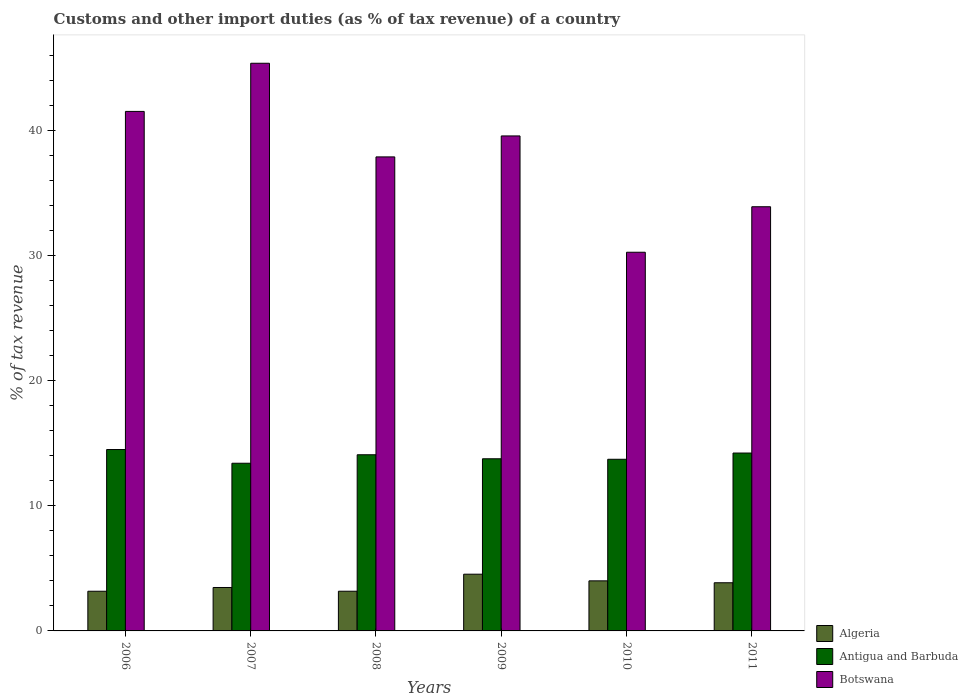How many groups of bars are there?
Your answer should be very brief. 6. Are the number of bars per tick equal to the number of legend labels?
Offer a terse response. Yes. What is the label of the 6th group of bars from the left?
Your response must be concise. 2011. What is the percentage of tax revenue from customs in Algeria in 2009?
Give a very brief answer. 4.53. Across all years, what is the maximum percentage of tax revenue from customs in Antigua and Barbuda?
Make the answer very short. 14.5. Across all years, what is the minimum percentage of tax revenue from customs in Botswana?
Provide a short and direct response. 30.27. In which year was the percentage of tax revenue from customs in Algeria minimum?
Provide a succinct answer. 2006. What is the total percentage of tax revenue from customs in Antigua and Barbuda in the graph?
Keep it short and to the point. 83.68. What is the difference between the percentage of tax revenue from customs in Algeria in 2009 and that in 2010?
Your answer should be very brief. 0.53. What is the difference between the percentage of tax revenue from customs in Antigua and Barbuda in 2008 and the percentage of tax revenue from customs in Algeria in 2006?
Provide a short and direct response. 10.91. What is the average percentage of tax revenue from customs in Algeria per year?
Offer a terse response. 3.7. In the year 2008, what is the difference between the percentage of tax revenue from customs in Antigua and Barbuda and percentage of tax revenue from customs in Botswana?
Provide a short and direct response. -23.81. What is the ratio of the percentage of tax revenue from customs in Antigua and Barbuda in 2006 to that in 2010?
Your answer should be very brief. 1.06. Is the difference between the percentage of tax revenue from customs in Antigua and Barbuda in 2008 and 2011 greater than the difference between the percentage of tax revenue from customs in Botswana in 2008 and 2011?
Your response must be concise. No. What is the difference between the highest and the second highest percentage of tax revenue from customs in Botswana?
Offer a terse response. 3.85. What is the difference between the highest and the lowest percentage of tax revenue from customs in Botswana?
Make the answer very short. 15.11. In how many years, is the percentage of tax revenue from customs in Botswana greater than the average percentage of tax revenue from customs in Botswana taken over all years?
Provide a short and direct response. 3. Is the sum of the percentage of tax revenue from customs in Botswana in 2007 and 2009 greater than the maximum percentage of tax revenue from customs in Antigua and Barbuda across all years?
Offer a terse response. Yes. What does the 3rd bar from the left in 2008 represents?
Your answer should be compact. Botswana. What does the 2nd bar from the right in 2009 represents?
Your response must be concise. Antigua and Barbuda. How many bars are there?
Your answer should be very brief. 18. Are all the bars in the graph horizontal?
Offer a terse response. No. How many years are there in the graph?
Ensure brevity in your answer.  6. Are the values on the major ticks of Y-axis written in scientific E-notation?
Your answer should be compact. No. How are the legend labels stacked?
Your answer should be compact. Vertical. What is the title of the graph?
Provide a short and direct response. Customs and other import duties (as % of tax revenue) of a country. Does "Isle of Man" appear as one of the legend labels in the graph?
Your answer should be compact. No. What is the label or title of the Y-axis?
Your response must be concise. % of tax revenue. What is the % of tax revenue of Algeria in 2006?
Ensure brevity in your answer.  3.17. What is the % of tax revenue of Antigua and Barbuda in 2006?
Give a very brief answer. 14.5. What is the % of tax revenue in Botswana in 2006?
Make the answer very short. 41.53. What is the % of tax revenue in Algeria in 2007?
Your answer should be very brief. 3.47. What is the % of tax revenue of Antigua and Barbuda in 2007?
Provide a succinct answer. 13.4. What is the % of tax revenue in Botswana in 2007?
Give a very brief answer. 45.37. What is the % of tax revenue of Algeria in 2008?
Offer a terse response. 3.17. What is the % of tax revenue in Antigua and Barbuda in 2008?
Give a very brief answer. 14.08. What is the % of tax revenue in Botswana in 2008?
Your answer should be very brief. 37.89. What is the % of tax revenue in Algeria in 2009?
Offer a terse response. 4.53. What is the % of tax revenue in Antigua and Barbuda in 2009?
Provide a succinct answer. 13.76. What is the % of tax revenue of Botswana in 2009?
Offer a very short reply. 39.57. What is the % of tax revenue in Algeria in 2010?
Provide a succinct answer. 4. What is the % of tax revenue in Antigua and Barbuda in 2010?
Ensure brevity in your answer.  13.72. What is the % of tax revenue of Botswana in 2010?
Your answer should be compact. 30.27. What is the % of tax revenue in Algeria in 2011?
Offer a very short reply. 3.85. What is the % of tax revenue in Antigua and Barbuda in 2011?
Ensure brevity in your answer.  14.22. What is the % of tax revenue of Botswana in 2011?
Provide a succinct answer. 33.91. Across all years, what is the maximum % of tax revenue in Algeria?
Ensure brevity in your answer.  4.53. Across all years, what is the maximum % of tax revenue of Antigua and Barbuda?
Offer a terse response. 14.5. Across all years, what is the maximum % of tax revenue in Botswana?
Provide a succinct answer. 45.37. Across all years, what is the minimum % of tax revenue in Algeria?
Provide a succinct answer. 3.17. Across all years, what is the minimum % of tax revenue in Antigua and Barbuda?
Your answer should be very brief. 13.4. Across all years, what is the minimum % of tax revenue of Botswana?
Your response must be concise. 30.27. What is the total % of tax revenue in Algeria in the graph?
Offer a very short reply. 22.2. What is the total % of tax revenue in Antigua and Barbuda in the graph?
Keep it short and to the point. 83.68. What is the total % of tax revenue of Botswana in the graph?
Your answer should be compact. 228.53. What is the difference between the % of tax revenue in Algeria in 2006 and that in 2007?
Your answer should be compact. -0.3. What is the difference between the % of tax revenue in Antigua and Barbuda in 2006 and that in 2007?
Provide a short and direct response. 1.1. What is the difference between the % of tax revenue of Botswana in 2006 and that in 2007?
Give a very brief answer. -3.85. What is the difference between the % of tax revenue in Algeria in 2006 and that in 2008?
Your response must be concise. -0. What is the difference between the % of tax revenue in Antigua and Barbuda in 2006 and that in 2008?
Give a very brief answer. 0.42. What is the difference between the % of tax revenue of Botswana in 2006 and that in 2008?
Your answer should be very brief. 3.64. What is the difference between the % of tax revenue of Algeria in 2006 and that in 2009?
Make the answer very short. -1.36. What is the difference between the % of tax revenue of Antigua and Barbuda in 2006 and that in 2009?
Your answer should be compact. 0.74. What is the difference between the % of tax revenue of Botswana in 2006 and that in 2009?
Your answer should be compact. 1.96. What is the difference between the % of tax revenue in Algeria in 2006 and that in 2010?
Your response must be concise. -0.83. What is the difference between the % of tax revenue of Antigua and Barbuda in 2006 and that in 2010?
Offer a very short reply. 0.78. What is the difference between the % of tax revenue in Botswana in 2006 and that in 2010?
Ensure brevity in your answer.  11.26. What is the difference between the % of tax revenue of Algeria in 2006 and that in 2011?
Make the answer very short. -0.68. What is the difference between the % of tax revenue of Antigua and Barbuda in 2006 and that in 2011?
Ensure brevity in your answer.  0.28. What is the difference between the % of tax revenue in Botswana in 2006 and that in 2011?
Give a very brief answer. 7.62. What is the difference between the % of tax revenue of Algeria in 2007 and that in 2008?
Offer a terse response. 0.3. What is the difference between the % of tax revenue of Antigua and Barbuda in 2007 and that in 2008?
Provide a succinct answer. -0.68. What is the difference between the % of tax revenue in Botswana in 2007 and that in 2008?
Make the answer very short. 7.48. What is the difference between the % of tax revenue of Algeria in 2007 and that in 2009?
Your answer should be compact. -1.06. What is the difference between the % of tax revenue in Antigua and Barbuda in 2007 and that in 2009?
Your answer should be compact. -0.36. What is the difference between the % of tax revenue of Botswana in 2007 and that in 2009?
Your answer should be very brief. 5.81. What is the difference between the % of tax revenue in Algeria in 2007 and that in 2010?
Your response must be concise. -0.53. What is the difference between the % of tax revenue in Antigua and Barbuda in 2007 and that in 2010?
Make the answer very short. -0.32. What is the difference between the % of tax revenue of Botswana in 2007 and that in 2010?
Offer a terse response. 15.11. What is the difference between the % of tax revenue in Algeria in 2007 and that in 2011?
Your response must be concise. -0.38. What is the difference between the % of tax revenue in Antigua and Barbuda in 2007 and that in 2011?
Ensure brevity in your answer.  -0.82. What is the difference between the % of tax revenue of Botswana in 2007 and that in 2011?
Your response must be concise. 11.47. What is the difference between the % of tax revenue in Algeria in 2008 and that in 2009?
Give a very brief answer. -1.36. What is the difference between the % of tax revenue of Antigua and Barbuda in 2008 and that in 2009?
Ensure brevity in your answer.  0.32. What is the difference between the % of tax revenue in Botswana in 2008 and that in 2009?
Provide a succinct answer. -1.68. What is the difference between the % of tax revenue in Algeria in 2008 and that in 2010?
Keep it short and to the point. -0.83. What is the difference between the % of tax revenue in Antigua and Barbuda in 2008 and that in 2010?
Your answer should be very brief. 0.36. What is the difference between the % of tax revenue of Botswana in 2008 and that in 2010?
Your answer should be very brief. 7.62. What is the difference between the % of tax revenue of Algeria in 2008 and that in 2011?
Provide a short and direct response. -0.68. What is the difference between the % of tax revenue of Antigua and Barbuda in 2008 and that in 2011?
Provide a succinct answer. -0.14. What is the difference between the % of tax revenue of Botswana in 2008 and that in 2011?
Give a very brief answer. 3.98. What is the difference between the % of tax revenue in Algeria in 2009 and that in 2010?
Provide a short and direct response. 0.53. What is the difference between the % of tax revenue in Antigua and Barbuda in 2009 and that in 2010?
Provide a short and direct response. 0.04. What is the difference between the % of tax revenue in Botswana in 2009 and that in 2010?
Make the answer very short. 9.3. What is the difference between the % of tax revenue in Algeria in 2009 and that in 2011?
Provide a short and direct response. 0.68. What is the difference between the % of tax revenue of Antigua and Barbuda in 2009 and that in 2011?
Your answer should be compact. -0.46. What is the difference between the % of tax revenue in Botswana in 2009 and that in 2011?
Your answer should be very brief. 5.66. What is the difference between the % of tax revenue of Algeria in 2010 and that in 2011?
Your answer should be compact. 0.15. What is the difference between the % of tax revenue in Antigua and Barbuda in 2010 and that in 2011?
Ensure brevity in your answer.  -0.5. What is the difference between the % of tax revenue of Botswana in 2010 and that in 2011?
Offer a very short reply. -3.64. What is the difference between the % of tax revenue in Algeria in 2006 and the % of tax revenue in Antigua and Barbuda in 2007?
Your response must be concise. -10.23. What is the difference between the % of tax revenue of Algeria in 2006 and the % of tax revenue of Botswana in 2007?
Give a very brief answer. -42.2. What is the difference between the % of tax revenue of Antigua and Barbuda in 2006 and the % of tax revenue of Botswana in 2007?
Ensure brevity in your answer.  -30.88. What is the difference between the % of tax revenue of Algeria in 2006 and the % of tax revenue of Antigua and Barbuda in 2008?
Your response must be concise. -10.91. What is the difference between the % of tax revenue of Algeria in 2006 and the % of tax revenue of Botswana in 2008?
Ensure brevity in your answer.  -34.72. What is the difference between the % of tax revenue in Antigua and Barbuda in 2006 and the % of tax revenue in Botswana in 2008?
Your answer should be very brief. -23.39. What is the difference between the % of tax revenue in Algeria in 2006 and the % of tax revenue in Antigua and Barbuda in 2009?
Your response must be concise. -10.59. What is the difference between the % of tax revenue in Algeria in 2006 and the % of tax revenue in Botswana in 2009?
Give a very brief answer. -36.4. What is the difference between the % of tax revenue in Antigua and Barbuda in 2006 and the % of tax revenue in Botswana in 2009?
Give a very brief answer. -25.07. What is the difference between the % of tax revenue in Algeria in 2006 and the % of tax revenue in Antigua and Barbuda in 2010?
Make the answer very short. -10.55. What is the difference between the % of tax revenue in Algeria in 2006 and the % of tax revenue in Botswana in 2010?
Provide a short and direct response. -27.1. What is the difference between the % of tax revenue in Antigua and Barbuda in 2006 and the % of tax revenue in Botswana in 2010?
Keep it short and to the point. -15.77. What is the difference between the % of tax revenue in Algeria in 2006 and the % of tax revenue in Antigua and Barbuda in 2011?
Provide a short and direct response. -11.05. What is the difference between the % of tax revenue of Algeria in 2006 and the % of tax revenue of Botswana in 2011?
Provide a short and direct response. -30.73. What is the difference between the % of tax revenue of Antigua and Barbuda in 2006 and the % of tax revenue of Botswana in 2011?
Give a very brief answer. -19.41. What is the difference between the % of tax revenue in Algeria in 2007 and the % of tax revenue in Antigua and Barbuda in 2008?
Keep it short and to the point. -10.61. What is the difference between the % of tax revenue in Algeria in 2007 and the % of tax revenue in Botswana in 2008?
Keep it short and to the point. -34.42. What is the difference between the % of tax revenue of Antigua and Barbuda in 2007 and the % of tax revenue of Botswana in 2008?
Offer a very short reply. -24.49. What is the difference between the % of tax revenue of Algeria in 2007 and the % of tax revenue of Antigua and Barbuda in 2009?
Offer a terse response. -10.29. What is the difference between the % of tax revenue of Algeria in 2007 and the % of tax revenue of Botswana in 2009?
Your answer should be very brief. -36.1. What is the difference between the % of tax revenue of Antigua and Barbuda in 2007 and the % of tax revenue of Botswana in 2009?
Make the answer very short. -26.16. What is the difference between the % of tax revenue of Algeria in 2007 and the % of tax revenue of Antigua and Barbuda in 2010?
Your answer should be compact. -10.25. What is the difference between the % of tax revenue of Algeria in 2007 and the % of tax revenue of Botswana in 2010?
Make the answer very short. -26.8. What is the difference between the % of tax revenue of Antigua and Barbuda in 2007 and the % of tax revenue of Botswana in 2010?
Ensure brevity in your answer.  -16.87. What is the difference between the % of tax revenue in Algeria in 2007 and the % of tax revenue in Antigua and Barbuda in 2011?
Give a very brief answer. -10.75. What is the difference between the % of tax revenue in Algeria in 2007 and the % of tax revenue in Botswana in 2011?
Provide a short and direct response. -30.44. What is the difference between the % of tax revenue in Antigua and Barbuda in 2007 and the % of tax revenue in Botswana in 2011?
Make the answer very short. -20.5. What is the difference between the % of tax revenue in Algeria in 2008 and the % of tax revenue in Antigua and Barbuda in 2009?
Your response must be concise. -10.59. What is the difference between the % of tax revenue in Algeria in 2008 and the % of tax revenue in Botswana in 2009?
Your answer should be compact. -36.39. What is the difference between the % of tax revenue of Antigua and Barbuda in 2008 and the % of tax revenue of Botswana in 2009?
Make the answer very short. -25.48. What is the difference between the % of tax revenue in Algeria in 2008 and the % of tax revenue in Antigua and Barbuda in 2010?
Provide a succinct answer. -10.55. What is the difference between the % of tax revenue in Algeria in 2008 and the % of tax revenue in Botswana in 2010?
Offer a very short reply. -27.1. What is the difference between the % of tax revenue in Antigua and Barbuda in 2008 and the % of tax revenue in Botswana in 2010?
Provide a succinct answer. -16.19. What is the difference between the % of tax revenue of Algeria in 2008 and the % of tax revenue of Antigua and Barbuda in 2011?
Ensure brevity in your answer.  -11.05. What is the difference between the % of tax revenue in Algeria in 2008 and the % of tax revenue in Botswana in 2011?
Ensure brevity in your answer.  -30.73. What is the difference between the % of tax revenue of Antigua and Barbuda in 2008 and the % of tax revenue of Botswana in 2011?
Keep it short and to the point. -19.82. What is the difference between the % of tax revenue in Algeria in 2009 and the % of tax revenue in Antigua and Barbuda in 2010?
Provide a short and direct response. -9.19. What is the difference between the % of tax revenue in Algeria in 2009 and the % of tax revenue in Botswana in 2010?
Give a very brief answer. -25.74. What is the difference between the % of tax revenue in Antigua and Barbuda in 2009 and the % of tax revenue in Botswana in 2010?
Your answer should be very brief. -16.51. What is the difference between the % of tax revenue of Algeria in 2009 and the % of tax revenue of Antigua and Barbuda in 2011?
Give a very brief answer. -9.68. What is the difference between the % of tax revenue of Algeria in 2009 and the % of tax revenue of Botswana in 2011?
Provide a succinct answer. -29.37. What is the difference between the % of tax revenue in Antigua and Barbuda in 2009 and the % of tax revenue in Botswana in 2011?
Your response must be concise. -20.15. What is the difference between the % of tax revenue in Algeria in 2010 and the % of tax revenue in Antigua and Barbuda in 2011?
Offer a very short reply. -10.22. What is the difference between the % of tax revenue of Algeria in 2010 and the % of tax revenue of Botswana in 2011?
Your answer should be compact. -29.9. What is the difference between the % of tax revenue in Antigua and Barbuda in 2010 and the % of tax revenue in Botswana in 2011?
Your answer should be very brief. -20.19. What is the average % of tax revenue of Algeria per year?
Make the answer very short. 3.7. What is the average % of tax revenue in Antigua and Barbuda per year?
Your response must be concise. 13.95. What is the average % of tax revenue in Botswana per year?
Your response must be concise. 38.09. In the year 2006, what is the difference between the % of tax revenue of Algeria and % of tax revenue of Antigua and Barbuda?
Your answer should be compact. -11.33. In the year 2006, what is the difference between the % of tax revenue in Algeria and % of tax revenue in Botswana?
Keep it short and to the point. -38.35. In the year 2006, what is the difference between the % of tax revenue in Antigua and Barbuda and % of tax revenue in Botswana?
Offer a terse response. -27.03. In the year 2007, what is the difference between the % of tax revenue of Algeria and % of tax revenue of Antigua and Barbuda?
Make the answer very short. -9.93. In the year 2007, what is the difference between the % of tax revenue in Algeria and % of tax revenue in Botswana?
Offer a very short reply. -41.9. In the year 2007, what is the difference between the % of tax revenue in Antigua and Barbuda and % of tax revenue in Botswana?
Your answer should be very brief. -31.97. In the year 2008, what is the difference between the % of tax revenue in Algeria and % of tax revenue in Antigua and Barbuda?
Offer a terse response. -10.91. In the year 2008, what is the difference between the % of tax revenue in Algeria and % of tax revenue in Botswana?
Your response must be concise. -34.72. In the year 2008, what is the difference between the % of tax revenue in Antigua and Barbuda and % of tax revenue in Botswana?
Your answer should be very brief. -23.81. In the year 2009, what is the difference between the % of tax revenue in Algeria and % of tax revenue in Antigua and Barbuda?
Keep it short and to the point. -9.23. In the year 2009, what is the difference between the % of tax revenue in Algeria and % of tax revenue in Botswana?
Your response must be concise. -35.03. In the year 2009, what is the difference between the % of tax revenue in Antigua and Barbuda and % of tax revenue in Botswana?
Offer a very short reply. -25.81. In the year 2010, what is the difference between the % of tax revenue in Algeria and % of tax revenue in Antigua and Barbuda?
Offer a very short reply. -9.72. In the year 2010, what is the difference between the % of tax revenue in Algeria and % of tax revenue in Botswana?
Your answer should be compact. -26.27. In the year 2010, what is the difference between the % of tax revenue in Antigua and Barbuda and % of tax revenue in Botswana?
Offer a very short reply. -16.55. In the year 2011, what is the difference between the % of tax revenue in Algeria and % of tax revenue in Antigua and Barbuda?
Provide a short and direct response. -10.37. In the year 2011, what is the difference between the % of tax revenue in Algeria and % of tax revenue in Botswana?
Keep it short and to the point. -30.06. In the year 2011, what is the difference between the % of tax revenue of Antigua and Barbuda and % of tax revenue of Botswana?
Keep it short and to the point. -19.69. What is the ratio of the % of tax revenue in Algeria in 2006 to that in 2007?
Your response must be concise. 0.91. What is the ratio of the % of tax revenue of Antigua and Barbuda in 2006 to that in 2007?
Keep it short and to the point. 1.08. What is the ratio of the % of tax revenue in Botswana in 2006 to that in 2007?
Give a very brief answer. 0.92. What is the ratio of the % of tax revenue in Algeria in 2006 to that in 2008?
Offer a very short reply. 1. What is the ratio of the % of tax revenue in Antigua and Barbuda in 2006 to that in 2008?
Your answer should be compact. 1.03. What is the ratio of the % of tax revenue in Botswana in 2006 to that in 2008?
Provide a short and direct response. 1.1. What is the ratio of the % of tax revenue of Algeria in 2006 to that in 2009?
Give a very brief answer. 0.7. What is the ratio of the % of tax revenue of Antigua and Barbuda in 2006 to that in 2009?
Offer a terse response. 1.05. What is the ratio of the % of tax revenue of Botswana in 2006 to that in 2009?
Offer a very short reply. 1.05. What is the ratio of the % of tax revenue of Algeria in 2006 to that in 2010?
Provide a short and direct response. 0.79. What is the ratio of the % of tax revenue in Antigua and Barbuda in 2006 to that in 2010?
Your answer should be very brief. 1.06. What is the ratio of the % of tax revenue in Botswana in 2006 to that in 2010?
Keep it short and to the point. 1.37. What is the ratio of the % of tax revenue in Algeria in 2006 to that in 2011?
Offer a terse response. 0.82. What is the ratio of the % of tax revenue in Antigua and Barbuda in 2006 to that in 2011?
Your response must be concise. 1.02. What is the ratio of the % of tax revenue in Botswana in 2006 to that in 2011?
Give a very brief answer. 1.22. What is the ratio of the % of tax revenue in Algeria in 2007 to that in 2008?
Ensure brevity in your answer.  1.09. What is the ratio of the % of tax revenue in Antigua and Barbuda in 2007 to that in 2008?
Make the answer very short. 0.95. What is the ratio of the % of tax revenue of Botswana in 2007 to that in 2008?
Give a very brief answer. 1.2. What is the ratio of the % of tax revenue in Algeria in 2007 to that in 2009?
Provide a succinct answer. 0.77. What is the ratio of the % of tax revenue in Antigua and Barbuda in 2007 to that in 2009?
Your answer should be very brief. 0.97. What is the ratio of the % of tax revenue in Botswana in 2007 to that in 2009?
Make the answer very short. 1.15. What is the ratio of the % of tax revenue of Algeria in 2007 to that in 2010?
Provide a short and direct response. 0.87. What is the ratio of the % of tax revenue in Antigua and Barbuda in 2007 to that in 2010?
Offer a very short reply. 0.98. What is the ratio of the % of tax revenue in Botswana in 2007 to that in 2010?
Offer a terse response. 1.5. What is the ratio of the % of tax revenue in Algeria in 2007 to that in 2011?
Offer a very short reply. 0.9. What is the ratio of the % of tax revenue of Antigua and Barbuda in 2007 to that in 2011?
Your answer should be very brief. 0.94. What is the ratio of the % of tax revenue of Botswana in 2007 to that in 2011?
Provide a succinct answer. 1.34. What is the ratio of the % of tax revenue of Algeria in 2008 to that in 2009?
Your answer should be very brief. 0.7. What is the ratio of the % of tax revenue in Antigua and Barbuda in 2008 to that in 2009?
Ensure brevity in your answer.  1.02. What is the ratio of the % of tax revenue in Botswana in 2008 to that in 2009?
Offer a very short reply. 0.96. What is the ratio of the % of tax revenue of Algeria in 2008 to that in 2010?
Your response must be concise. 0.79. What is the ratio of the % of tax revenue in Antigua and Barbuda in 2008 to that in 2010?
Make the answer very short. 1.03. What is the ratio of the % of tax revenue in Botswana in 2008 to that in 2010?
Your response must be concise. 1.25. What is the ratio of the % of tax revenue in Algeria in 2008 to that in 2011?
Offer a very short reply. 0.82. What is the ratio of the % of tax revenue in Botswana in 2008 to that in 2011?
Give a very brief answer. 1.12. What is the ratio of the % of tax revenue in Algeria in 2009 to that in 2010?
Keep it short and to the point. 1.13. What is the ratio of the % of tax revenue in Antigua and Barbuda in 2009 to that in 2010?
Keep it short and to the point. 1. What is the ratio of the % of tax revenue in Botswana in 2009 to that in 2010?
Provide a succinct answer. 1.31. What is the ratio of the % of tax revenue in Algeria in 2009 to that in 2011?
Keep it short and to the point. 1.18. What is the ratio of the % of tax revenue in Antigua and Barbuda in 2009 to that in 2011?
Your response must be concise. 0.97. What is the ratio of the % of tax revenue in Botswana in 2009 to that in 2011?
Provide a short and direct response. 1.17. What is the ratio of the % of tax revenue of Algeria in 2010 to that in 2011?
Make the answer very short. 1.04. What is the ratio of the % of tax revenue in Botswana in 2010 to that in 2011?
Offer a very short reply. 0.89. What is the difference between the highest and the second highest % of tax revenue in Algeria?
Ensure brevity in your answer.  0.53. What is the difference between the highest and the second highest % of tax revenue in Antigua and Barbuda?
Provide a succinct answer. 0.28. What is the difference between the highest and the second highest % of tax revenue in Botswana?
Make the answer very short. 3.85. What is the difference between the highest and the lowest % of tax revenue of Algeria?
Your answer should be compact. 1.36. What is the difference between the highest and the lowest % of tax revenue in Antigua and Barbuda?
Your answer should be very brief. 1.1. What is the difference between the highest and the lowest % of tax revenue in Botswana?
Your answer should be very brief. 15.11. 